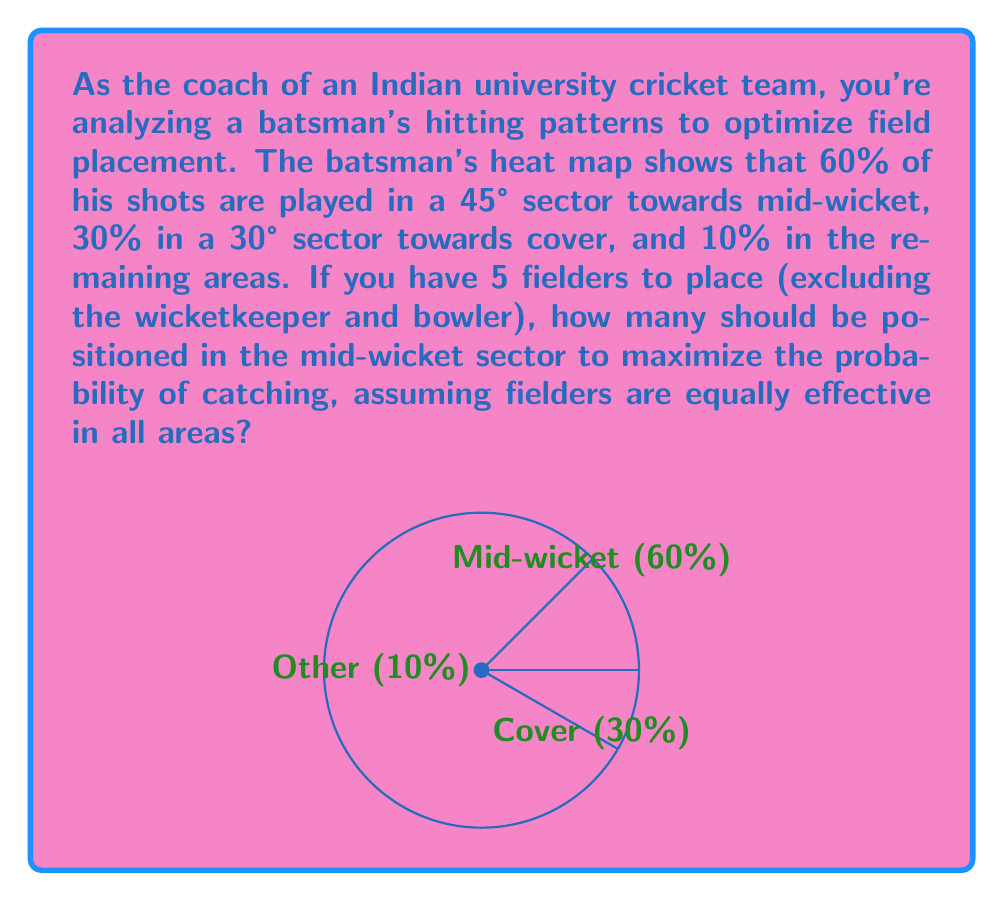Teach me how to tackle this problem. Let's approach this step-by-step:

1) First, we need to calculate the probability of a catch per fielder in each sector:

   Mid-wicket: $P_{mw} = \frac{0.60}{45°} = 0.0133$ per degree
   Cover: $P_c = \frac{0.30}{30°} = 0.0100$ per degree
   Other: $P_o = \frac{0.10}{285°} \approx 0.0004$ per degree

2) The expected number of catches in each sector is proportional to the probability per degree multiplied by the number of fielders in that sector.

3) Let $x$ be the number of fielders in the mid-wicket sector. Then, the number in the cover sector should be proportional to its probability density:

   $\frac{30 * 0.0100}{45 * 0.0133} * x \approx 0.5x$

4) The remaining fielders will be in the other areas:

   $5 - x - 0.5x = 4.5 - 1.5x$

5) Now, we can set up an equation to maximize the total expected catches:

   $E(\text{catches}) = 45 * 0.0133x + 30 * 0.0100 * 0.5x + 285 * 0.0004 * (4.5 - 1.5x)$

6) Simplifying:

   $E(\text{catches}) = 0.5985x + 0.15x + 0.114 - 0.0171x = 0.7314x + 0.114$

7) This is a linear function in $x$, so the maximum will occur at one of the extreme values of $x$. The possible values for $x$ are 0, 1, 2, 3, or 4 (we can't place all 5 fielders in one sector as we need at least one in the cover sector).

8) The maximum value occurs when $x = 3$, which means 3 fielders in the mid-wicket sector, 1 in the cover sector (0.5 * 3 rounded to the nearest integer), and 1 in the other areas.
Answer: 3 fielders in mid-wicket sector 